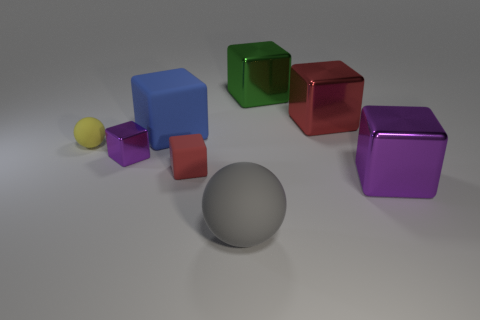Subtract all large red metallic blocks. How many blocks are left? 5 Add 1 rubber spheres. How many objects exist? 9 Subtract all gray balls. How many balls are left? 1 Subtract 1 spheres. How many spheres are left? 1 Subtract all blocks. How many objects are left? 2 Subtract all purple cylinders. How many cyan balls are left? 0 Add 6 small red matte cubes. How many small red matte cubes exist? 7 Subtract 0 brown spheres. How many objects are left? 8 Subtract all red blocks. Subtract all blue balls. How many blocks are left? 4 Subtract all blue rubber blocks. Subtract all tiny yellow things. How many objects are left? 6 